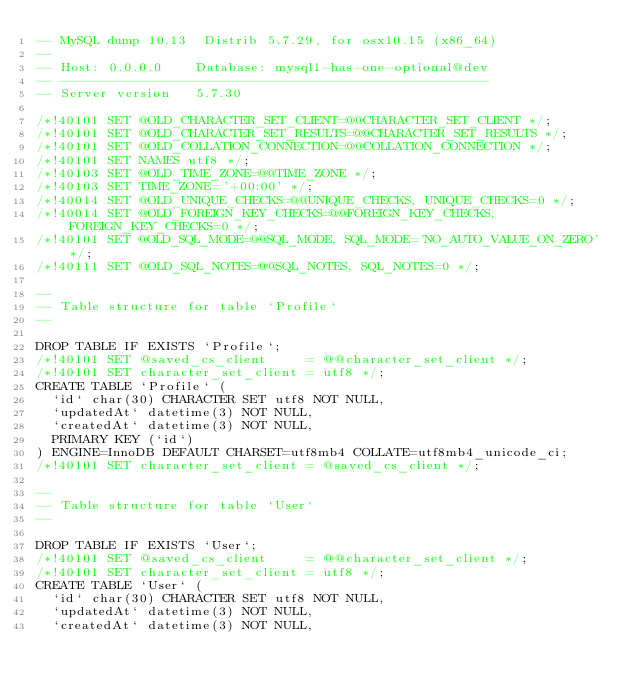Convert code to text. <code><loc_0><loc_0><loc_500><loc_500><_SQL_>-- MySQL dump 10.13  Distrib 5.7.29, for osx10.15 (x86_64)
--
-- Host: 0.0.0.0    Database: mysql1-has-one-optional@dev
-- ------------------------------------------------------
-- Server version	5.7.30

/*!40101 SET @OLD_CHARACTER_SET_CLIENT=@@CHARACTER_SET_CLIENT */;
/*!40101 SET @OLD_CHARACTER_SET_RESULTS=@@CHARACTER_SET_RESULTS */;
/*!40101 SET @OLD_COLLATION_CONNECTION=@@COLLATION_CONNECTION */;
/*!40101 SET NAMES utf8 */;
/*!40103 SET @OLD_TIME_ZONE=@@TIME_ZONE */;
/*!40103 SET TIME_ZONE='+00:00' */;
/*!40014 SET @OLD_UNIQUE_CHECKS=@@UNIQUE_CHECKS, UNIQUE_CHECKS=0 */;
/*!40014 SET @OLD_FOREIGN_KEY_CHECKS=@@FOREIGN_KEY_CHECKS, FOREIGN_KEY_CHECKS=0 */;
/*!40101 SET @OLD_SQL_MODE=@@SQL_MODE, SQL_MODE='NO_AUTO_VALUE_ON_ZERO' */;
/*!40111 SET @OLD_SQL_NOTES=@@SQL_NOTES, SQL_NOTES=0 */;

--
-- Table structure for table `Profile`
--

DROP TABLE IF EXISTS `Profile`;
/*!40101 SET @saved_cs_client     = @@character_set_client */;
/*!40101 SET character_set_client = utf8 */;
CREATE TABLE `Profile` (
  `id` char(30) CHARACTER SET utf8 NOT NULL,
  `updatedAt` datetime(3) NOT NULL,
  `createdAt` datetime(3) NOT NULL,
  PRIMARY KEY (`id`)
) ENGINE=InnoDB DEFAULT CHARSET=utf8mb4 COLLATE=utf8mb4_unicode_ci;
/*!40101 SET character_set_client = @saved_cs_client */;

--
-- Table structure for table `User`
--

DROP TABLE IF EXISTS `User`;
/*!40101 SET @saved_cs_client     = @@character_set_client */;
/*!40101 SET character_set_client = utf8 */;
CREATE TABLE `User` (
  `id` char(30) CHARACTER SET utf8 NOT NULL,
  `updatedAt` datetime(3) NOT NULL,
  `createdAt` datetime(3) NOT NULL,</code> 